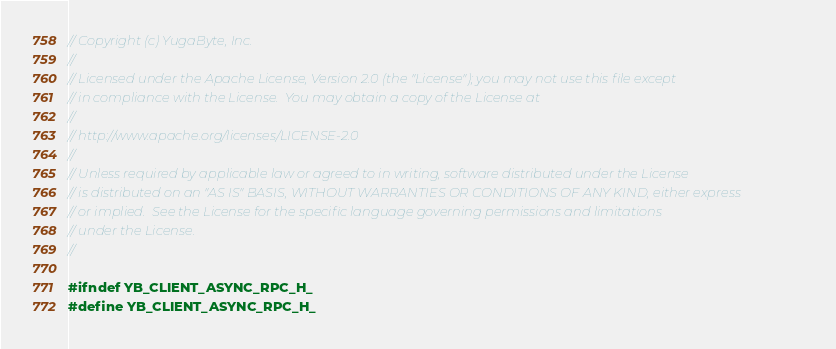Convert code to text. <code><loc_0><loc_0><loc_500><loc_500><_C_>// Copyright (c) YugaByte, Inc.
//
// Licensed under the Apache License, Version 2.0 (the "License"); you may not use this file except
// in compliance with the License.  You may obtain a copy of the License at
//
// http://www.apache.org/licenses/LICENSE-2.0
//
// Unless required by applicable law or agreed to in writing, software distributed under the License
// is distributed on an "AS IS" BASIS, WITHOUT WARRANTIES OR CONDITIONS OF ANY KIND, either express
// or implied.  See the License for the specific language governing permissions and limitations
// under the License.
//

#ifndef YB_CLIENT_ASYNC_RPC_H_
#define YB_CLIENT_ASYNC_RPC_H_
</code> 